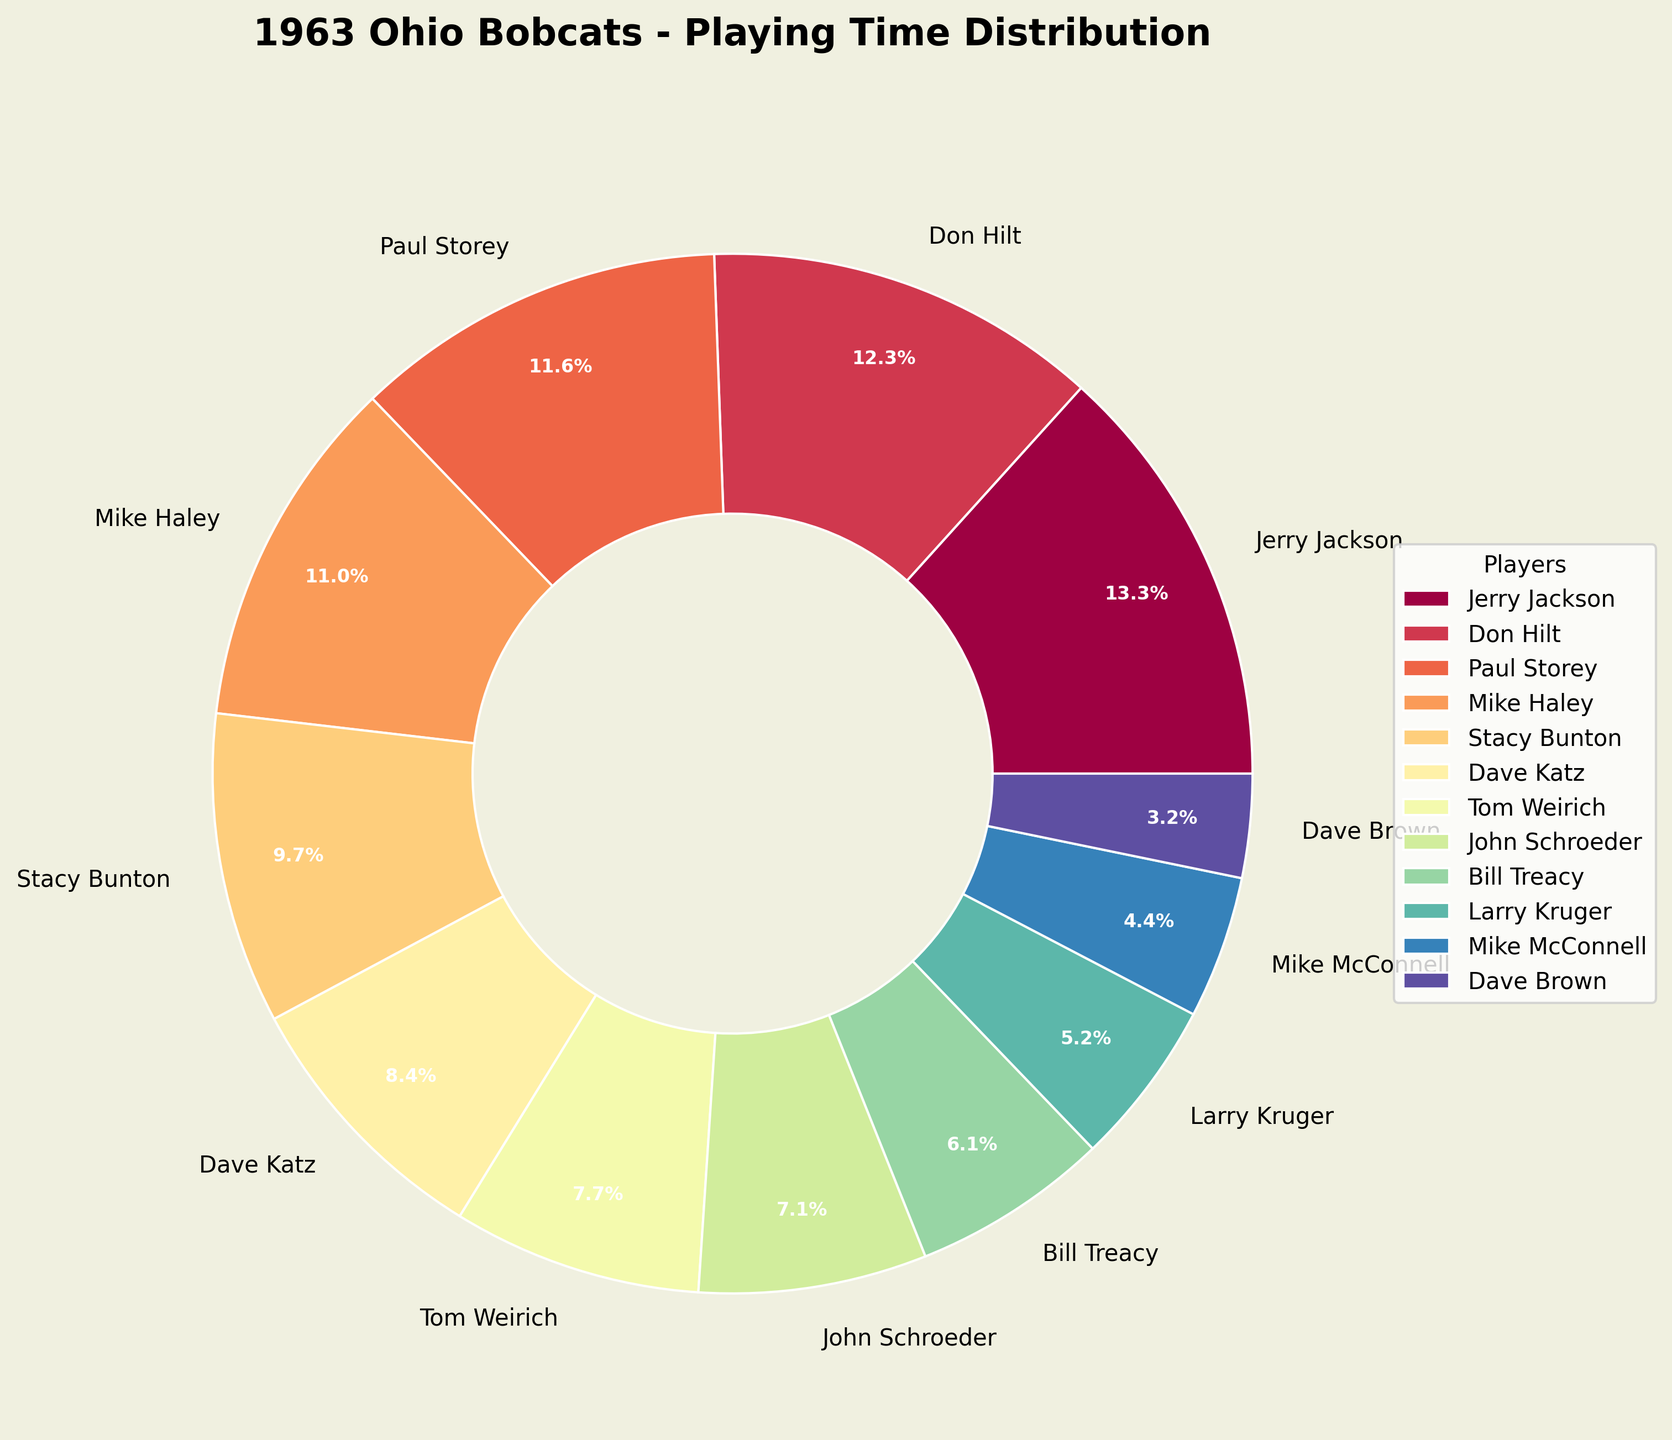Which player had the highest allocation of playing time? To determine the player with the highest allocation of playing time, look at the player with the largest wedge in the pie chart. Jerry Jackson has the largest segment.
Answer: Jerry Jackson Which players had more than 10% of the total playing time? Identify players with wedges labeled as more than 10%. Jerry Jackson, Don Hilt, Paul Storey, and Mike Haley have percentages above 10%.
Answer: Jerry Jackson, Don Hilt, Paul Storey, Mike Haley How does the playing time of Stacy Bunton compare to that of Mike Haley? Look at the wedges for both Stacy Bunton and Mike Haley. Stacy Bunton’s wedge is smaller than Mike Haley’s, indicating that Haley had more playing time.
Answer: Mike Haley had more What is the combined playing time percentage of Jerry Jackson and Don Hilt? Add the percentages from the wedges of Jerry Jackson (22.5%) and Don Hilt (20.7%). This results in 22.5 + 20.7 = 43.2%.
Answer: 43.2% Who played the least amount of time, and what was their percentage? Look for the smallest wedge in the pie chart, which belongs to Dave Brown. Check the percentage label on his wedge.
Answer: Dave Brown, 3.1% What is the difference in playing time percentages between Tom Weirich and Dave Katz? Referring to the wedges, Tom Weirich has 13.1%, and Dave Katz has 14.2%. The difference is 14.2 - 13.1 = 1.1%.
Answer: 1.1% What proportion of the total playing time was allocated to players who played between 6.5% and 13.5%? Identify players within this range: Stacy Bunton (16.4%), Dave Katz (14.2%), Tom Weirich (13.1%), John Schroeder (12.0%), and Bill Treacy (10.3%). Sum their percentages: 16.4 + 14.2 + 13.1 + 12.0 + 10.3 = 66%.
Answer: 66% Which players had nearly equal playing times, and what were their percentages? Look for wedges of similar sizes. Paul Storey and Mike Haley had nearly equal times, with 19.7% and 18.6% respectively.
Answer: Paul Storey (19.7%), Mike Haley (18.6%) What is the average playing time percentage of the top 4 players? Calculate average: Jerry Jackson (22.5%), Don Hilt (20.7%), Paul Storey (19.7%), and Mike Haley (18.6%). Average is (22.5 + 20.7 + 19.7 + 18.6) / 4 = 20.4%.
Answer: 20.4% 